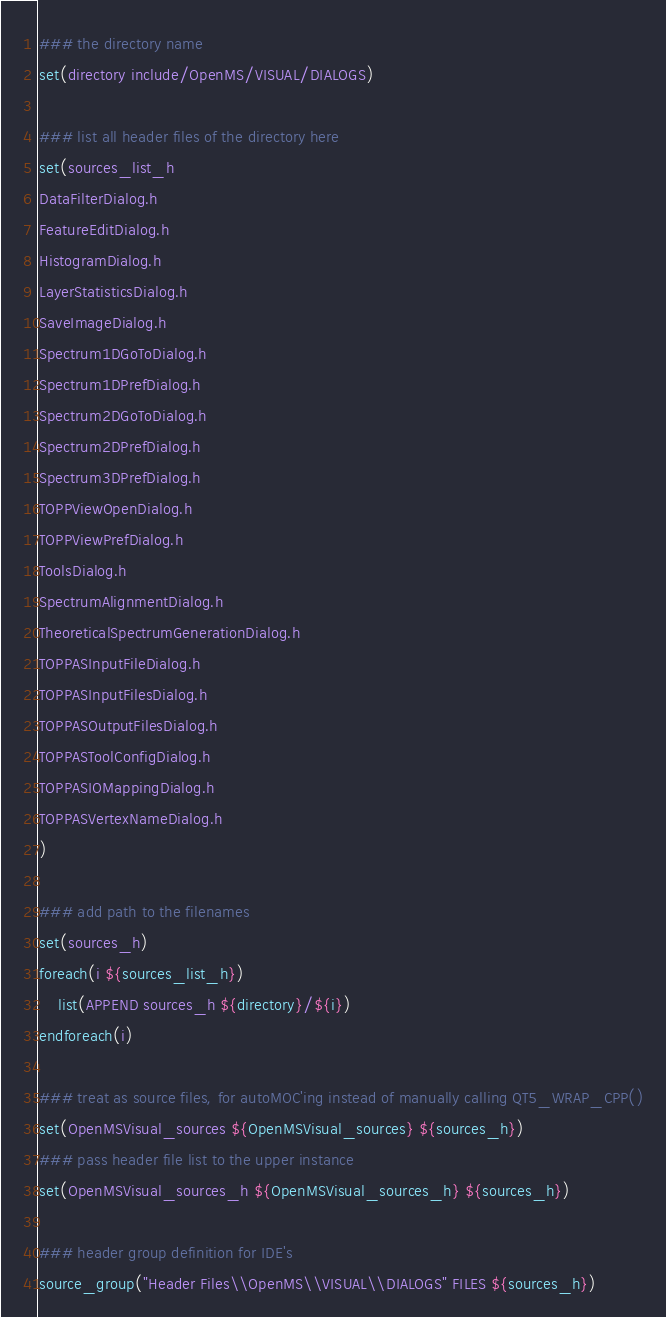Convert code to text. <code><loc_0><loc_0><loc_500><loc_500><_CMake_>### the directory name
set(directory include/OpenMS/VISUAL/DIALOGS)

### list all header files of the directory here
set(sources_list_h
DataFilterDialog.h
FeatureEditDialog.h
HistogramDialog.h
LayerStatisticsDialog.h
SaveImageDialog.h
Spectrum1DGoToDialog.h
Spectrum1DPrefDialog.h
Spectrum2DGoToDialog.h
Spectrum2DPrefDialog.h
Spectrum3DPrefDialog.h
TOPPViewOpenDialog.h
TOPPViewPrefDialog.h
ToolsDialog.h
SpectrumAlignmentDialog.h
TheoreticalSpectrumGenerationDialog.h
TOPPASInputFileDialog.h
TOPPASInputFilesDialog.h
TOPPASOutputFilesDialog.h
TOPPASToolConfigDialog.h
TOPPASIOMappingDialog.h
TOPPASVertexNameDialog.h
)

### add path to the filenames
set(sources_h)
foreach(i ${sources_list_h})
	list(APPEND sources_h ${directory}/${i})
endforeach(i)

### treat as source files, for autoMOC'ing instead of manually calling QT5_WRAP_CPP()
set(OpenMSVisual_sources ${OpenMSVisual_sources} ${sources_h})
### pass header file list to the upper instance
set(OpenMSVisual_sources_h ${OpenMSVisual_sources_h} ${sources_h})

### header group definition for IDE's
source_group("Header Files\\OpenMS\\VISUAL\\DIALOGS" FILES ${sources_h})

</code> 